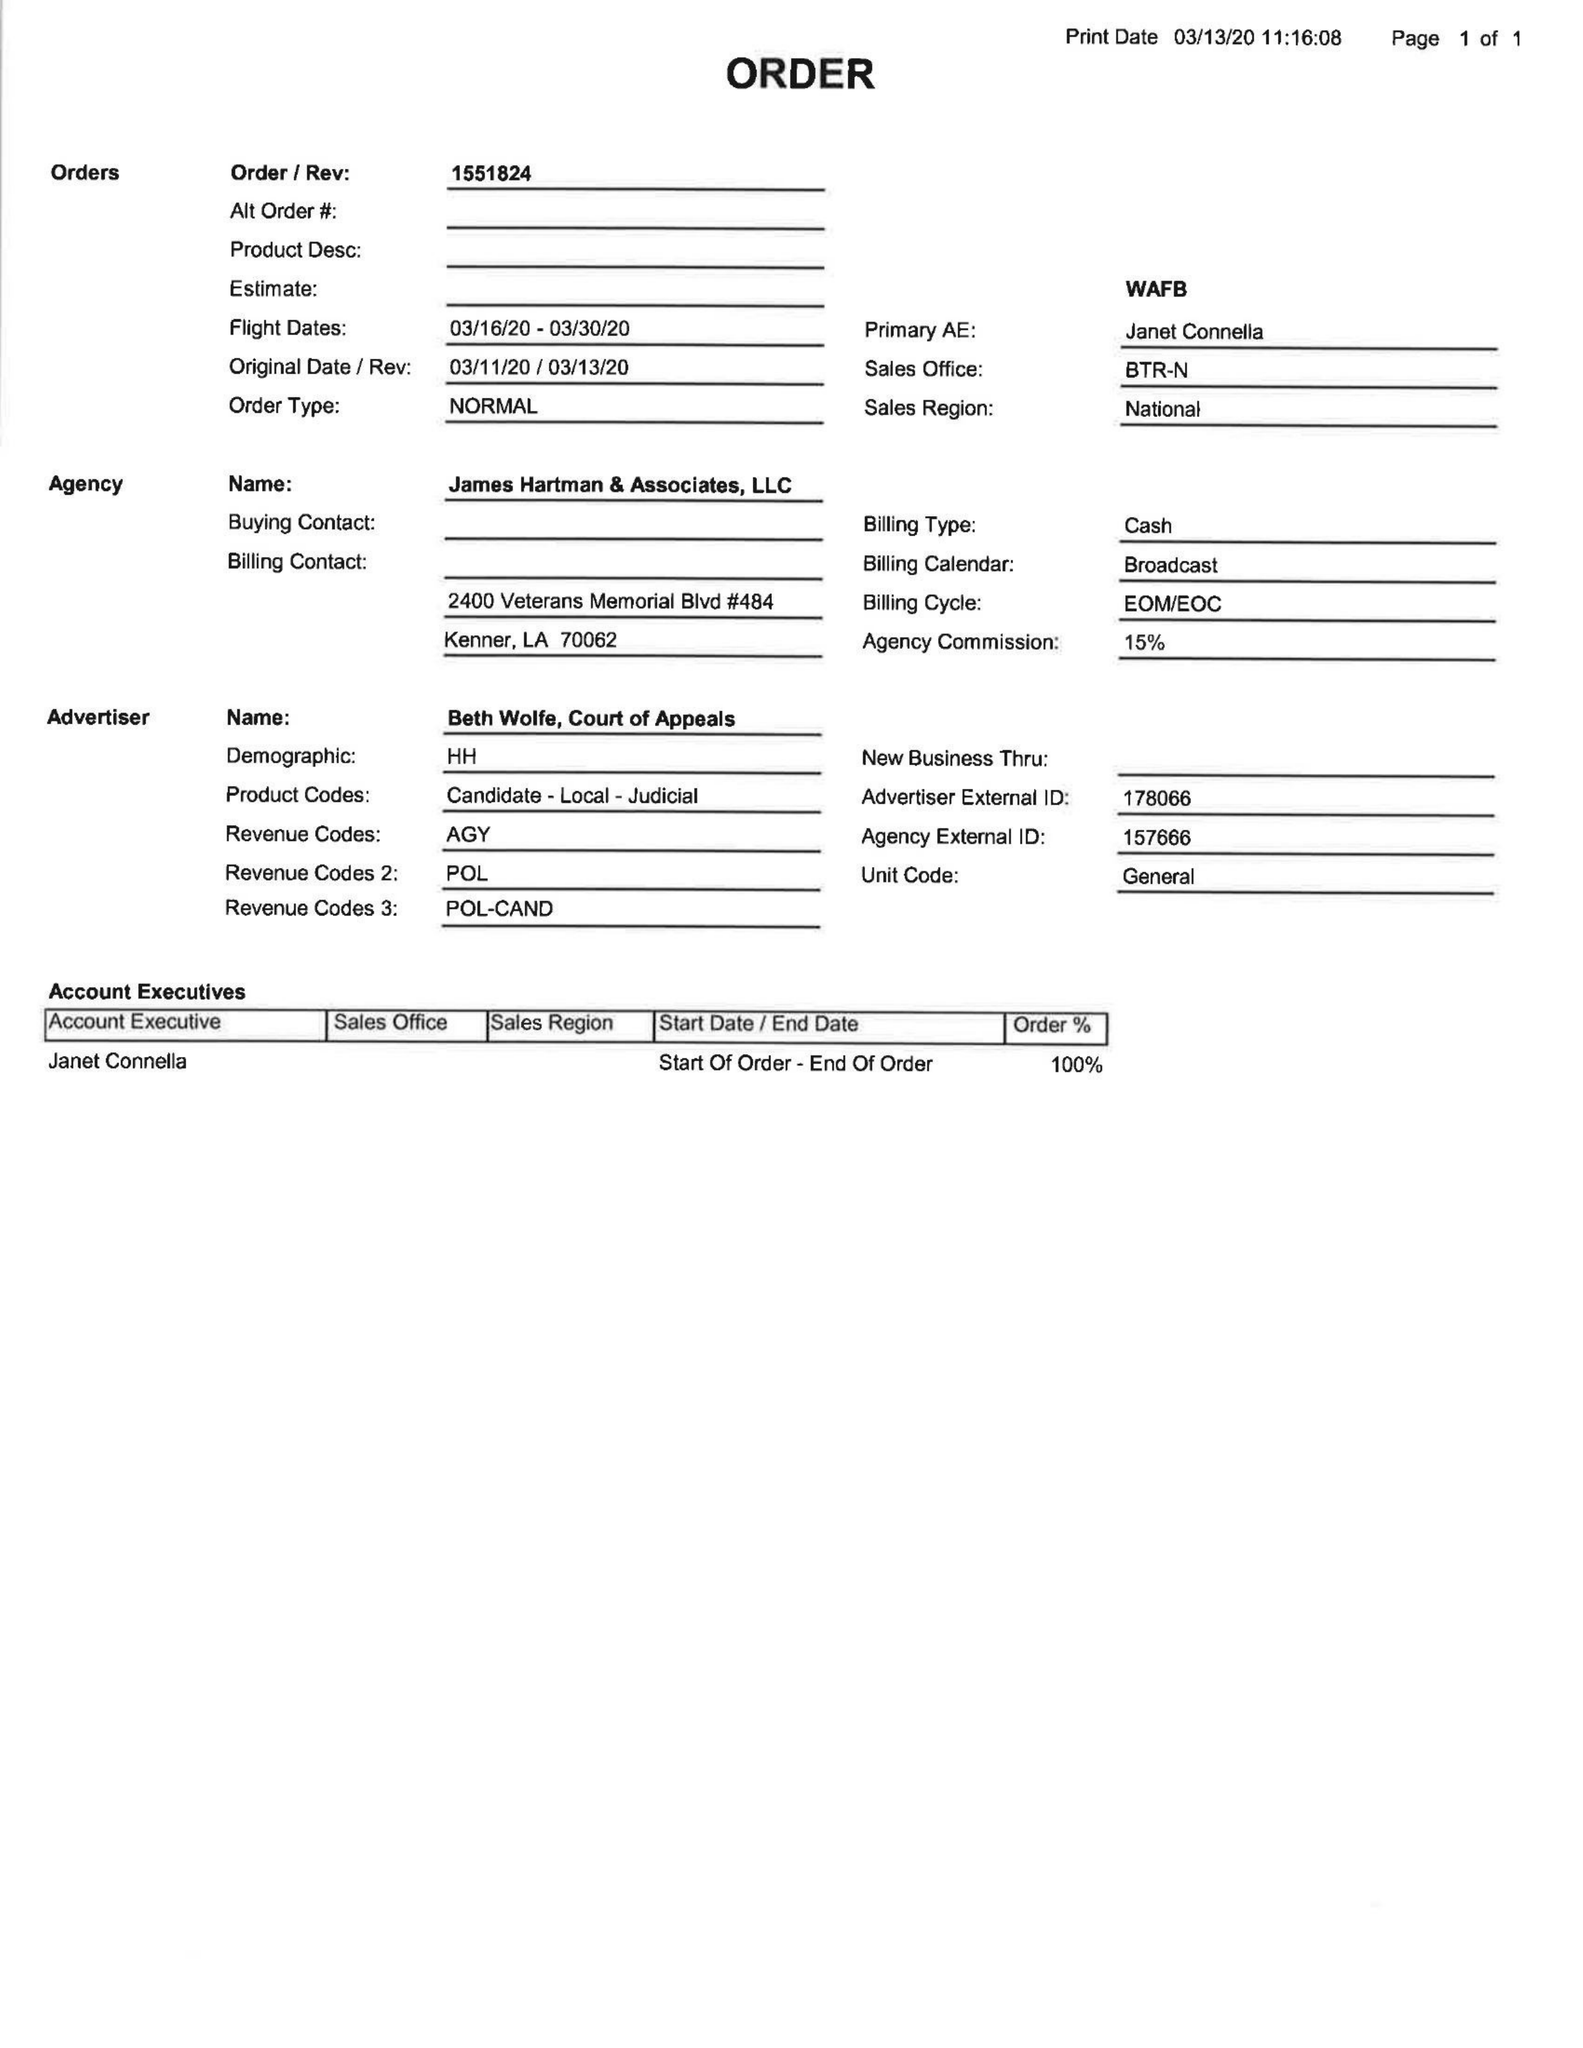What is the value for the contract_num?
Answer the question using a single word or phrase. 1551824 